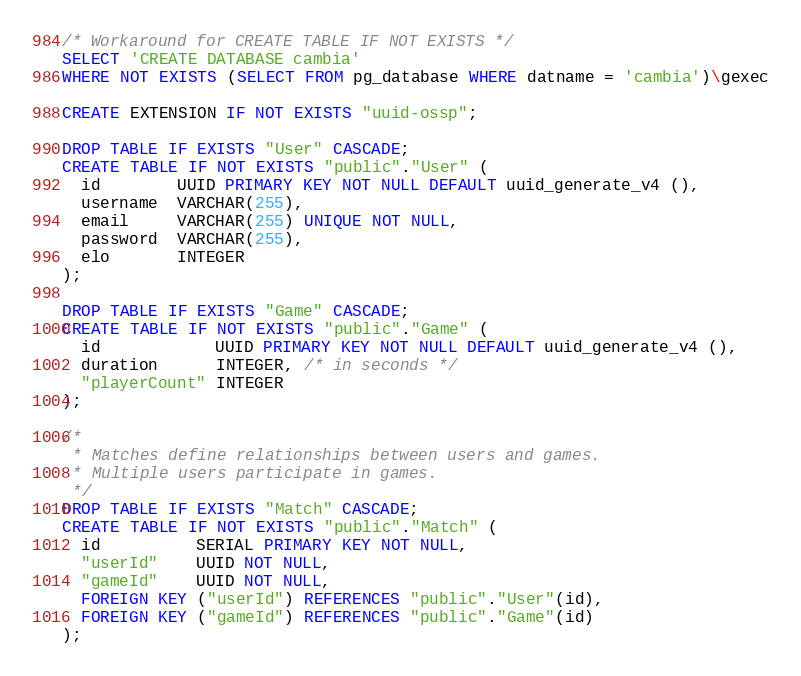<code> <loc_0><loc_0><loc_500><loc_500><_SQL_>/* Workaround for CREATE TABLE IF NOT EXISTS */
SELECT 'CREATE DATABASE cambia'
WHERE NOT EXISTS (SELECT FROM pg_database WHERE datname = 'cambia')\gexec

CREATE EXTENSION IF NOT EXISTS "uuid-ossp";

DROP TABLE IF EXISTS "User" CASCADE;
CREATE TABLE IF NOT EXISTS "public"."User" (
  id        UUID PRIMARY KEY NOT NULL DEFAULT uuid_generate_v4 (),
  username  VARCHAR(255),
  email     VARCHAR(255) UNIQUE NOT NULL,
  password  VARCHAR(255),
  elo       INTEGER
);

DROP TABLE IF EXISTS "Game" CASCADE;
CREATE TABLE IF NOT EXISTS "public"."Game" (
  id            UUID PRIMARY KEY NOT NULL DEFAULT uuid_generate_v4 (),
  duration      INTEGER, /* in seconds */
  "playerCount" INTEGER
);

/*
 * Matches define relationships between users and games.
 * Multiple users participate in games.
 */
DROP TABLE IF EXISTS "Match" CASCADE;
CREATE TABLE IF NOT EXISTS "public"."Match" (
  id          SERIAL PRIMARY KEY NOT NULL,
  "userId"    UUID NOT NULL,
  "gameId"    UUID NOT NULL,
  FOREIGN KEY ("userId") REFERENCES "public"."User"(id),
  FOREIGN KEY ("gameId") REFERENCES "public"."Game"(id)
);
</code> 